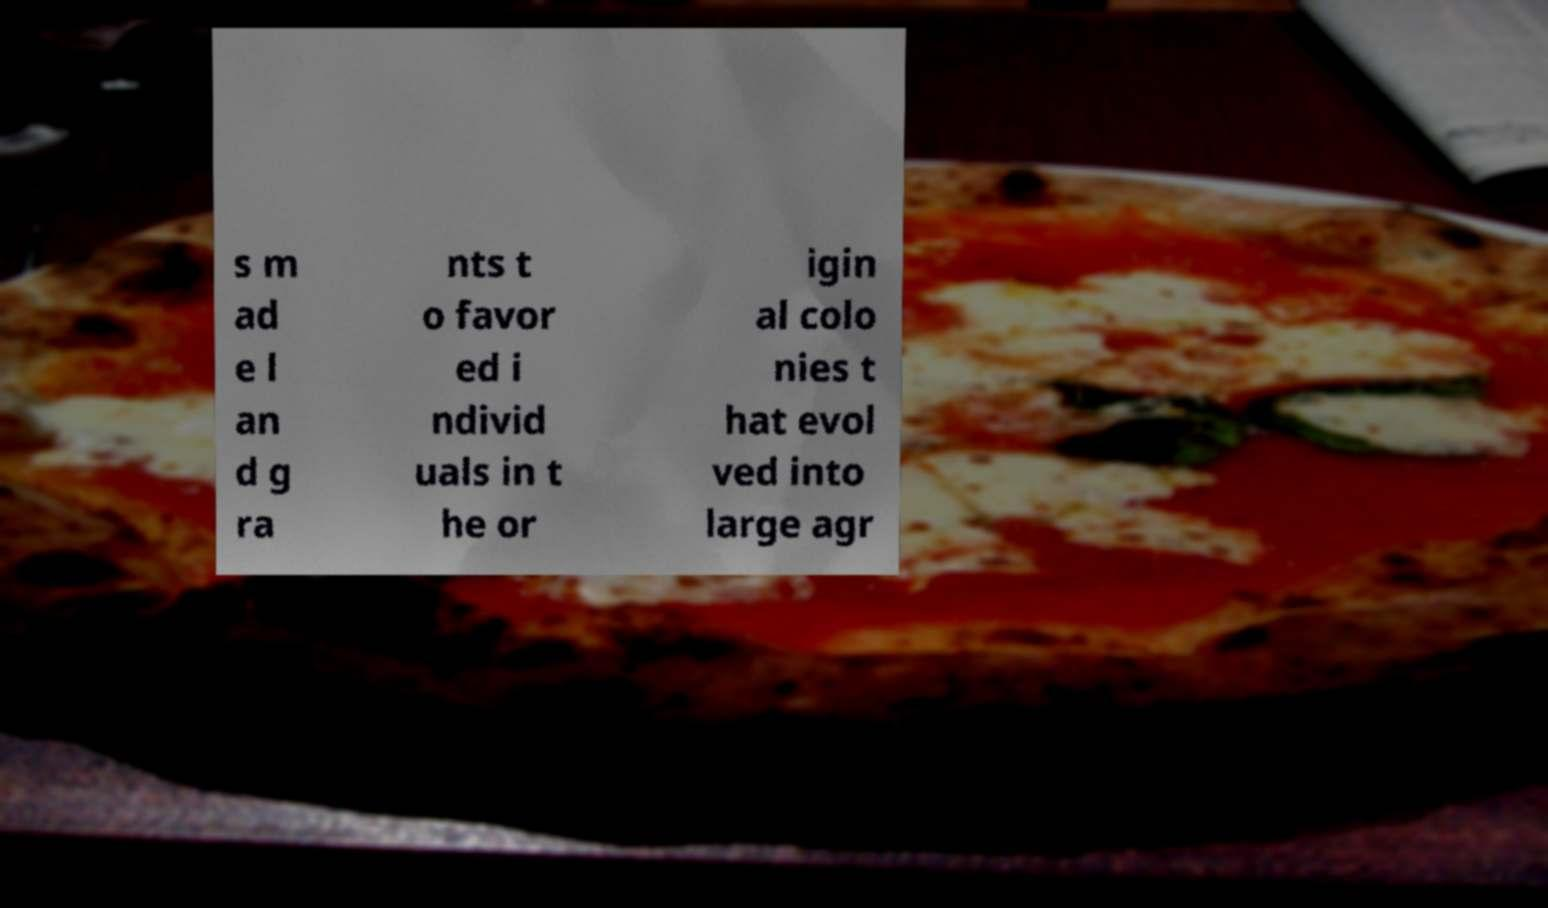What messages or text are displayed in this image? I need them in a readable, typed format. s m ad e l an d g ra nts t o favor ed i ndivid uals in t he or igin al colo nies t hat evol ved into large agr 